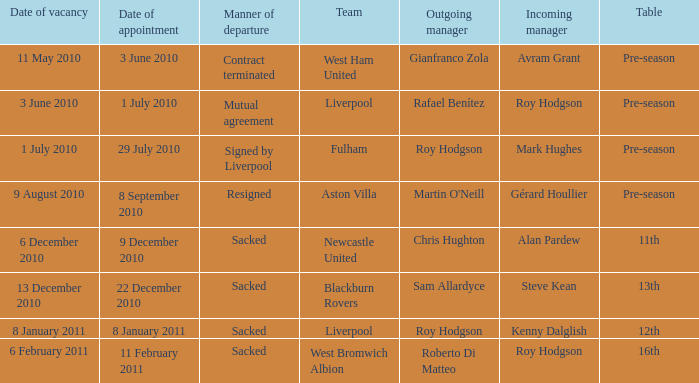What was the date of appointment for incoming manager Roy Hodgson and the team is Liverpool? 1 July 2010. Help me parse the entirety of this table. {'header': ['Date of vacancy', 'Date of appointment', 'Manner of departure', 'Team', 'Outgoing manager', 'Incoming manager', 'Table'], 'rows': [['11 May 2010', '3 June 2010', 'Contract terminated', 'West Ham United', 'Gianfranco Zola', 'Avram Grant', 'Pre-season'], ['3 June 2010', '1 July 2010', 'Mutual agreement', 'Liverpool', 'Rafael Benítez', 'Roy Hodgson', 'Pre-season'], ['1 July 2010', '29 July 2010', 'Signed by Liverpool', 'Fulham', 'Roy Hodgson', 'Mark Hughes', 'Pre-season'], ['9 August 2010', '8 September 2010', 'Resigned', 'Aston Villa', "Martin O'Neill", 'Gérard Houllier', 'Pre-season'], ['6 December 2010', '9 December 2010', 'Sacked', 'Newcastle United', 'Chris Hughton', 'Alan Pardew', '11th'], ['13 December 2010', '22 December 2010', 'Sacked', 'Blackburn Rovers', 'Sam Allardyce', 'Steve Kean', '13th'], ['8 January 2011', '8 January 2011', 'Sacked', 'Liverpool', 'Roy Hodgson', 'Kenny Dalglish', '12th'], ['6 February 2011', '11 February 2011', 'Sacked', 'West Bromwich Albion', 'Roberto Di Matteo', 'Roy Hodgson', '16th']]} 